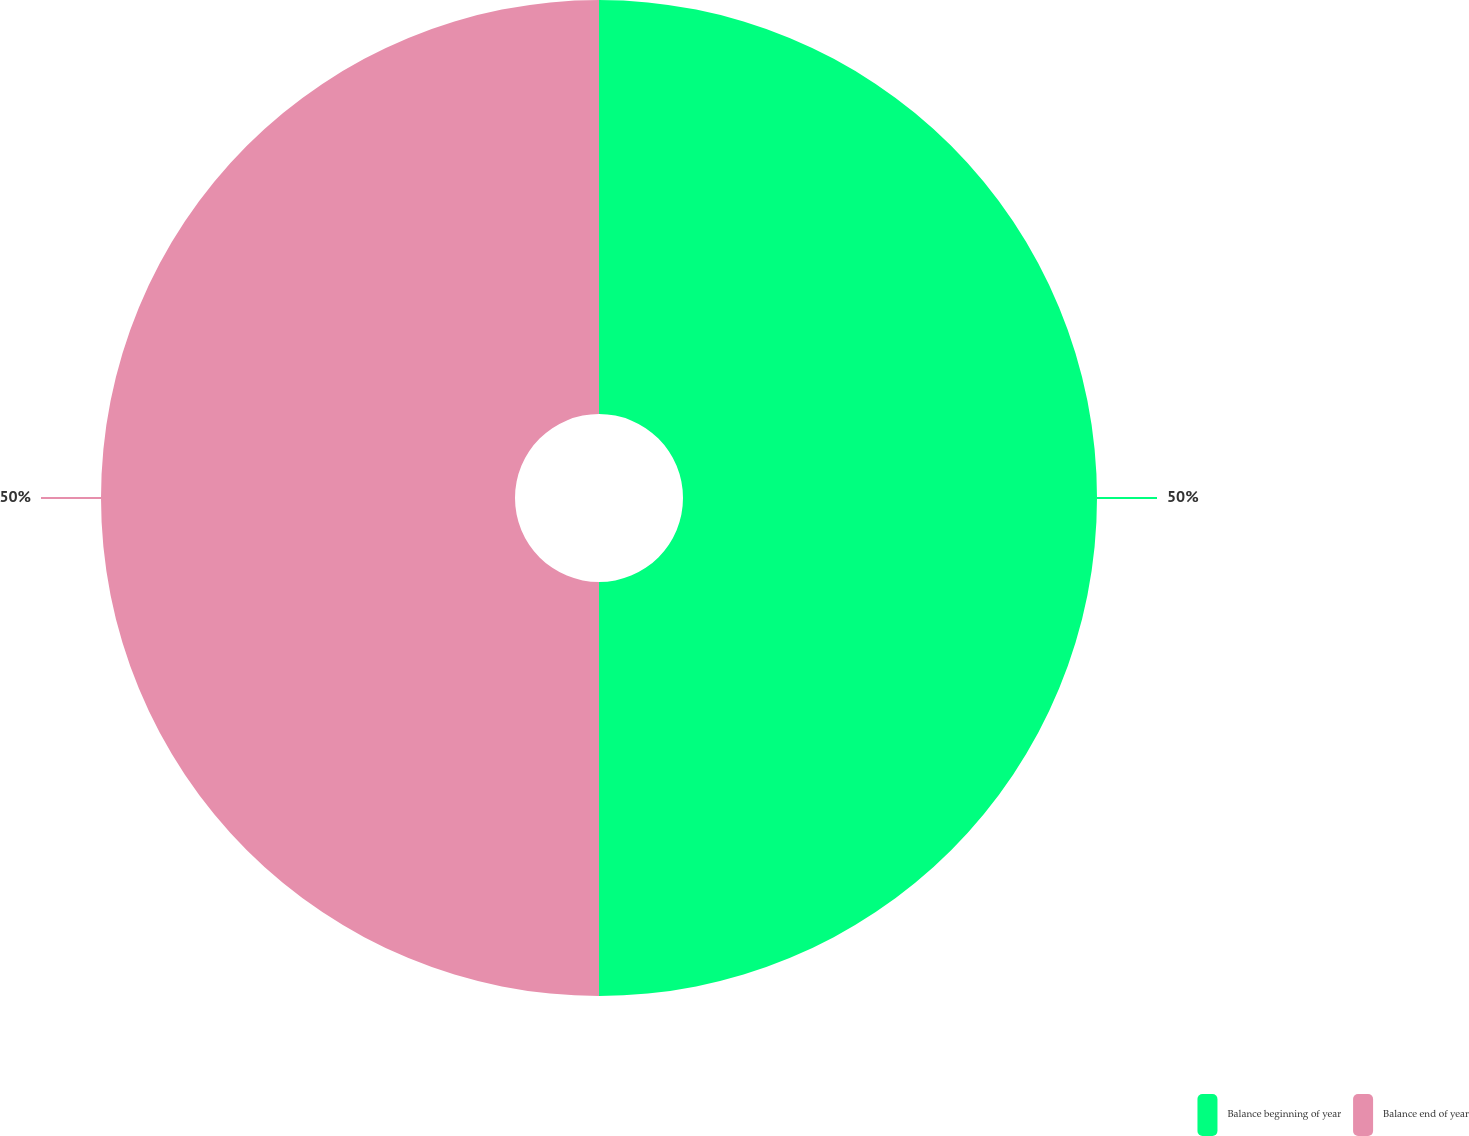Convert chart. <chart><loc_0><loc_0><loc_500><loc_500><pie_chart><fcel>Balance beginning of year<fcel>Balance end of year<nl><fcel>50.0%<fcel>50.0%<nl></chart> 